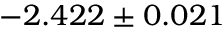<formula> <loc_0><loc_0><loc_500><loc_500>- 2 . 4 2 2 \pm 0 . 0 2 1</formula> 